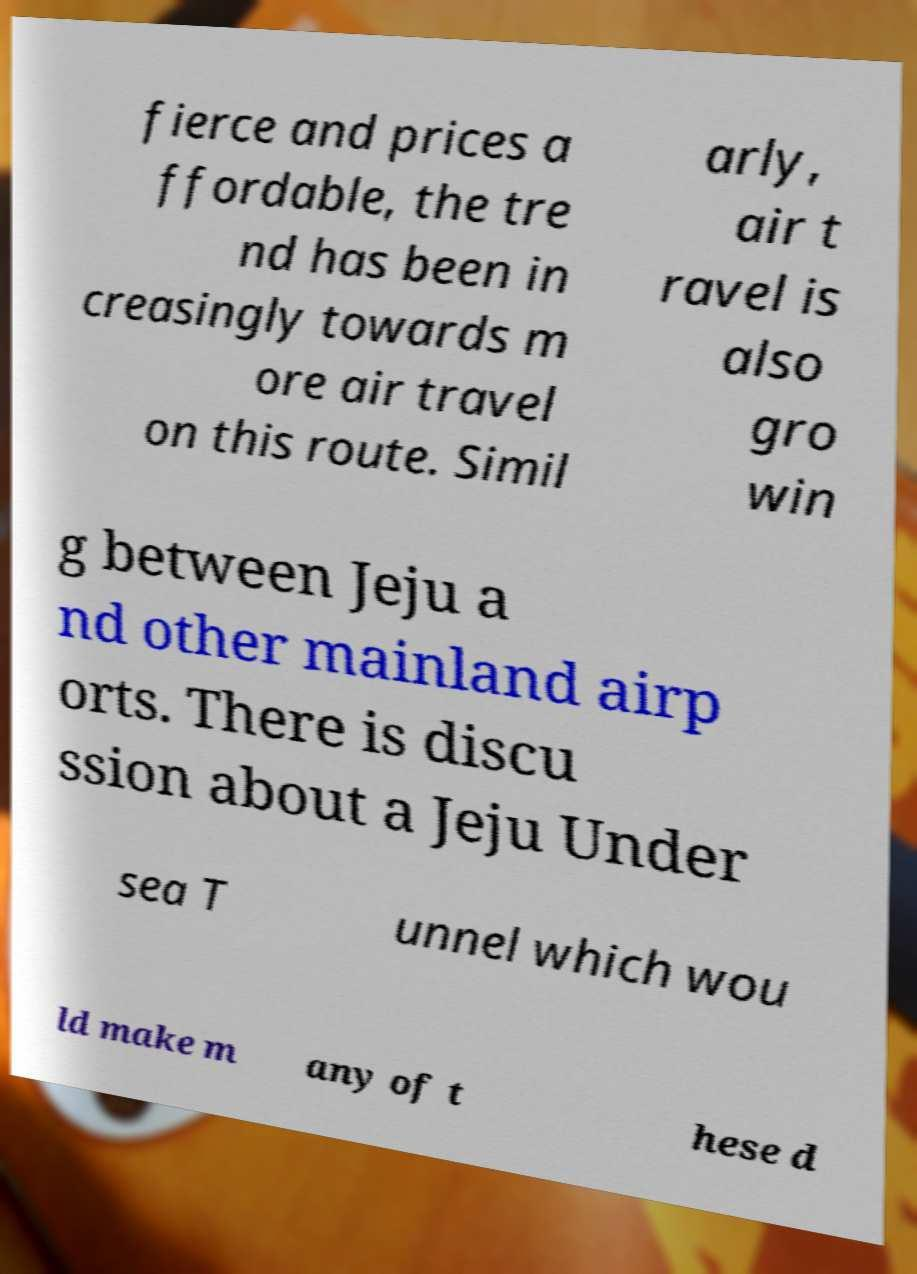Please read and relay the text visible in this image. What does it say? fierce and prices a ffordable, the tre nd has been in creasingly towards m ore air travel on this route. Simil arly, air t ravel is also gro win g between Jeju a nd other mainland airp orts. There is discu ssion about a Jeju Under sea T unnel which wou ld make m any of t hese d 